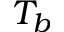<formula> <loc_0><loc_0><loc_500><loc_500>T _ { b }</formula> 